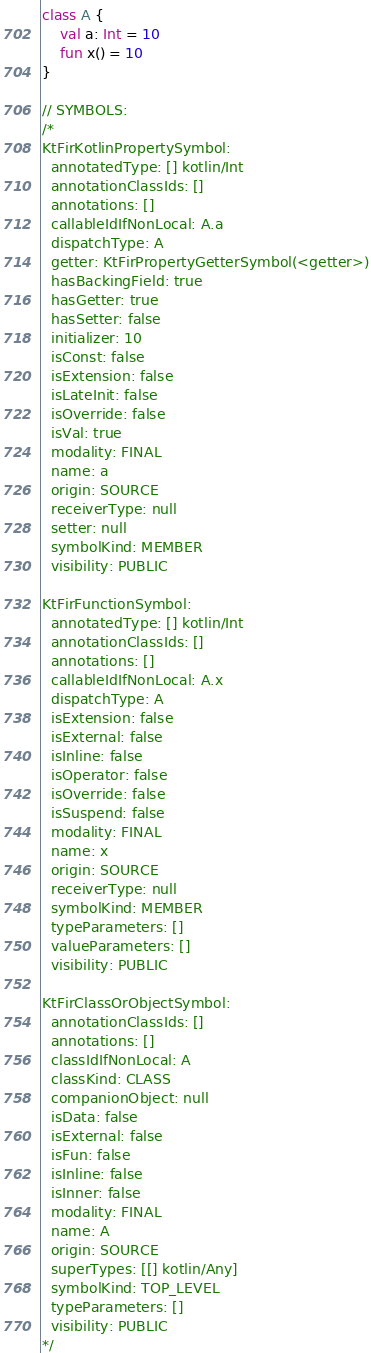Convert code to text. <code><loc_0><loc_0><loc_500><loc_500><_Kotlin_>class A {
    val a: Int = 10
    fun x() = 10
}

// SYMBOLS:
/*
KtFirKotlinPropertySymbol:
  annotatedType: [] kotlin/Int
  annotationClassIds: []
  annotations: []
  callableIdIfNonLocal: A.a
  dispatchType: A
  getter: KtFirPropertyGetterSymbol(<getter>)
  hasBackingField: true
  hasGetter: true
  hasSetter: false
  initializer: 10
  isConst: false
  isExtension: false
  isLateInit: false
  isOverride: false
  isVal: true
  modality: FINAL
  name: a
  origin: SOURCE
  receiverType: null
  setter: null
  symbolKind: MEMBER
  visibility: PUBLIC

KtFirFunctionSymbol:
  annotatedType: [] kotlin/Int
  annotationClassIds: []
  annotations: []
  callableIdIfNonLocal: A.x
  dispatchType: A
  isExtension: false
  isExternal: false
  isInline: false
  isOperator: false
  isOverride: false
  isSuspend: false
  modality: FINAL
  name: x
  origin: SOURCE
  receiverType: null
  symbolKind: MEMBER
  typeParameters: []
  valueParameters: []
  visibility: PUBLIC

KtFirClassOrObjectSymbol:
  annotationClassIds: []
  annotations: []
  classIdIfNonLocal: A
  classKind: CLASS
  companionObject: null
  isData: false
  isExternal: false
  isFun: false
  isInline: false
  isInner: false
  modality: FINAL
  name: A
  origin: SOURCE
  superTypes: [[] kotlin/Any]
  symbolKind: TOP_LEVEL
  typeParameters: []
  visibility: PUBLIC
*/
</code> 